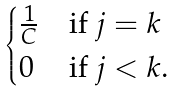Convert formula to latex. <formula><loc_0><loc_0><loc_500><loc_500>\begin{cases} \frac { 1 } { C } & \text {if $j=k$} \\ 0 & \text {if $j<k$.} \end{cases}</formula> 